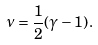<formula> <loc_0><loc_0><loc_500><loc_500>\nu = \frac { 1 } { 2 } ( \gamma - 1 ) \, .</formula> 